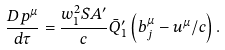Convert formula to latex. <formula><loc_0><loc_0><loc_500><loc_500>\frac { D p ^ { \mu } } { d \tau } = \frac { w _ { 1 } ^ { 2 } S A ^ { \prime } } { c } \bar { Q } ^ { \prime } _ { 1 } \left ( b _ { j } ^ { \mu } - u ^ { \mu } / c \right ) .</formula> 